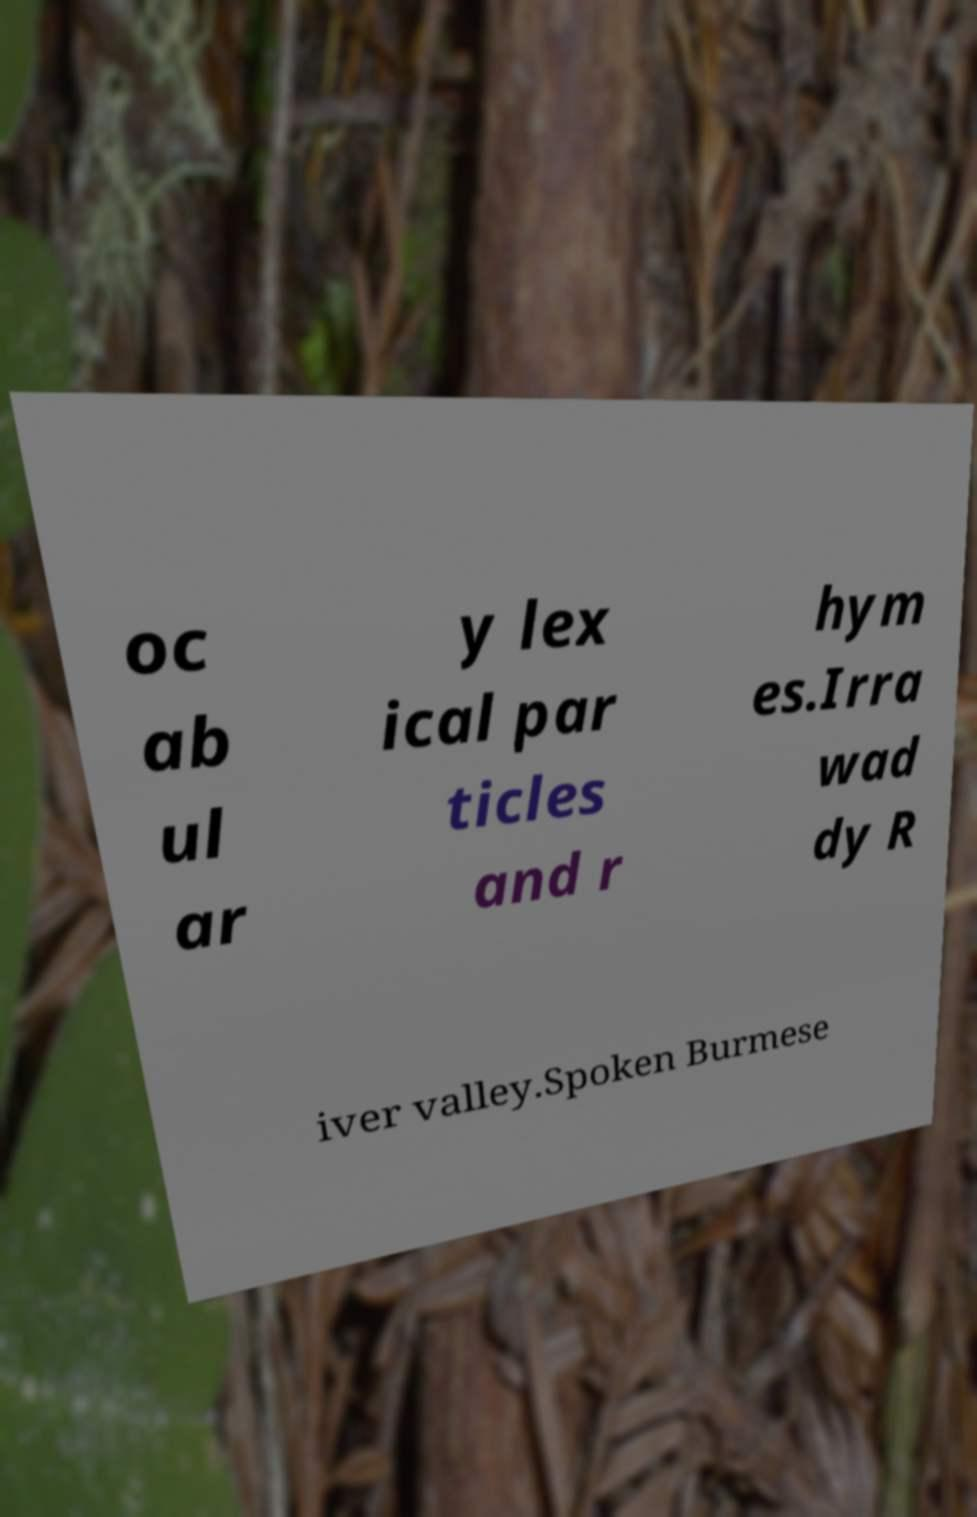There's text embedded in this image that I need extracted. Can you transcribe it verbatim? oc ab ul ar y lex ical par ticles and r hym es.Irra wad dy R iver valley.Spoken Burmese 